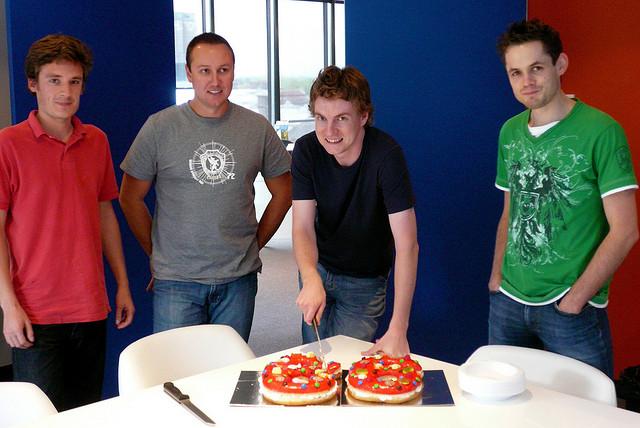Do the people appear happy or sad?
Concise answer only. Happy. Is there a knife not being held?
Give a very brief answer. Yes. Who holds the knife?
Be succinct. Man in black shirt. How many men are wearing white?
Answer briefly. 0. What color is the cake?
Concise answer only. Red. Are the people formally dressed?
Short answer required. No. What color is the flower in her hair?
Write a very short answer. None. Are they in uniform?
Short answer required. No. 